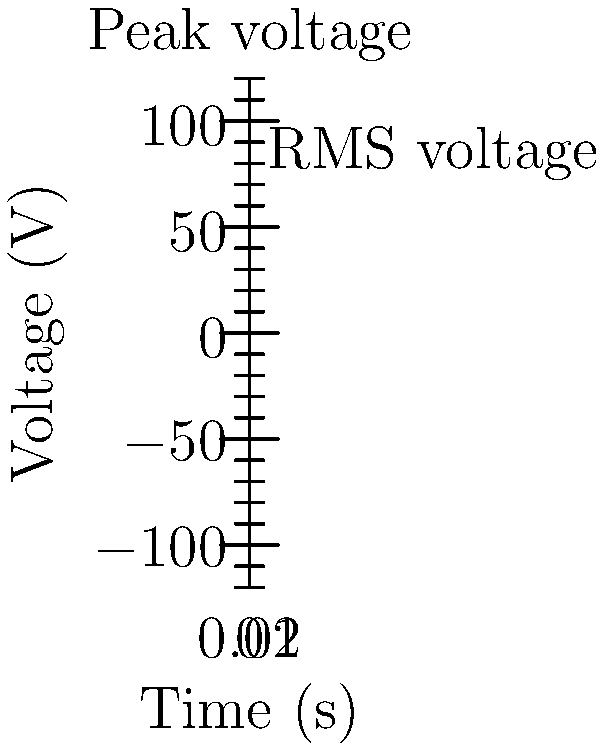The graph shows the voltage vs. time for an AC current. If the peak voltage is 120 V, what is the RMS (Root Mean Square) voltage? To find the RMS voltage from the peak voltage in an AC circuit, we can follow these steps:

1. Recall the relationship between peak voltage and RMS voltage:
   $V_{RMS} = \frac{V_{peak}}{\sqrt{2}}$

2. We are given that the peak voltage is 120 V:
   $V_{peak} = 120$ V

3. Substitute the peak voltage into the formula:
   $V_{RMS} = \frac{120}{\sqrt{2}}$

4. Simplify:
   $V_{RMS} = 120 \cdot \frac{1}{\sqrt{2}} \approx 120 \cdot 0.7071 \approx 84.85$ V

5. Round to a reasonable number of significant figures:
   $V_{RMS} \approx 85$ V

Therefore, the RMS voltage is approximately 85 V.
Answer: 85 V 